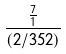Convert formula to latex. <formula><loc_0><loc_0><loc_500><loc_500>\frac { \frac { 7 } { 1 } } { ( 2 / 3 5 2 ) }</formula> 